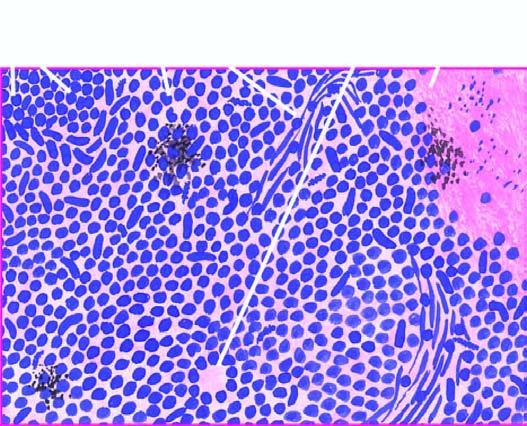what are the tumour cells arranged in?
Answer the question using a single word or phrase. Sheets 